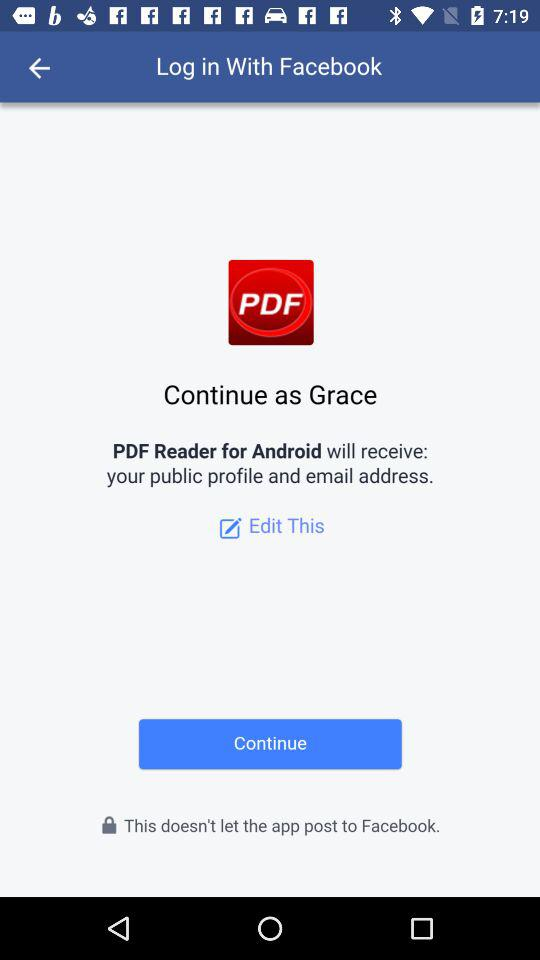What is the name of the user? The name of the user is Grace. 